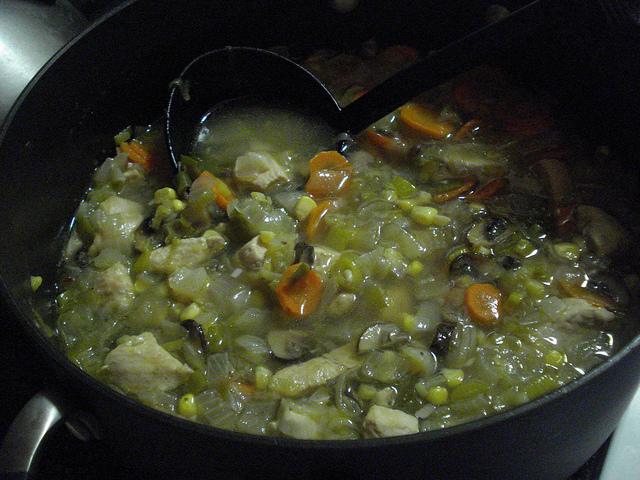What kind of pan is the food being cooked in?
Keep it brief. Skillet. Is there any cereal in the pot?
Short answer required. No. Can vegetarians eat this?
Answer briefly. No. What is the green veggie?
Give a very brief answer. Peas. Is that kidney beans in the pan?
Be succinct. No. Have you ever made a stew like that?
Write a very short answer. Yes. Does this soup have mushrooms?
Quick response, please. Yes. What vegetable is being cooked?
Give a very brief answer. Carrots. What color is the ladle?
Quick response, please. Black. 